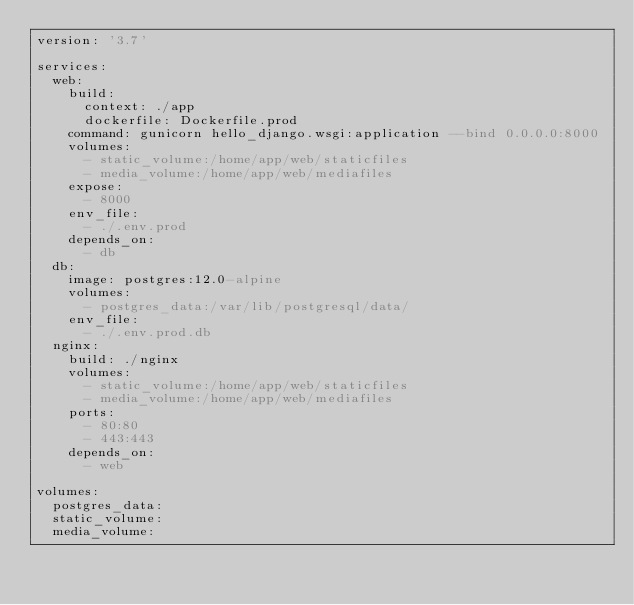Convert code to text. <code><loc_0><loc_0><loc_500><loc_500><_YAML_>version: '3.7'

services:
  web:
    build:
      context: ./app
      dockerfile: Dockerfile.prod
    command: gunicorn hello_django.wsgi:application --bind 0.0.0.0:8000
    volumes:
      - static_volume:/home/app/web/staticfiles
      - media_volume:/home/app/web/mediafiles
    expose:
      - 8000
    env_file:
      - ./.env.prod
    depends_on:
      - db
  db:
    image: postgres:12.0-alpine
    volumes:
      - postgres_data:/var/lib/postgresql/data/
    env_file:
      - ./.env.prod.db
  nginx:
    build: ./nginx
    volumes:
      - static_volume:/home/app/web/staticfiles
      - media_volume:/home/app/web/mediafiles
    ports:
      - 80:80
      - 443:443
    depends_on:
      - web

volumes:
  postgres_data:
  static_volume:
  media_volume:
</code> 